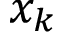<formula> <loc_0><loc_0><loc_500><loc_500>x _ { k }</formula> 